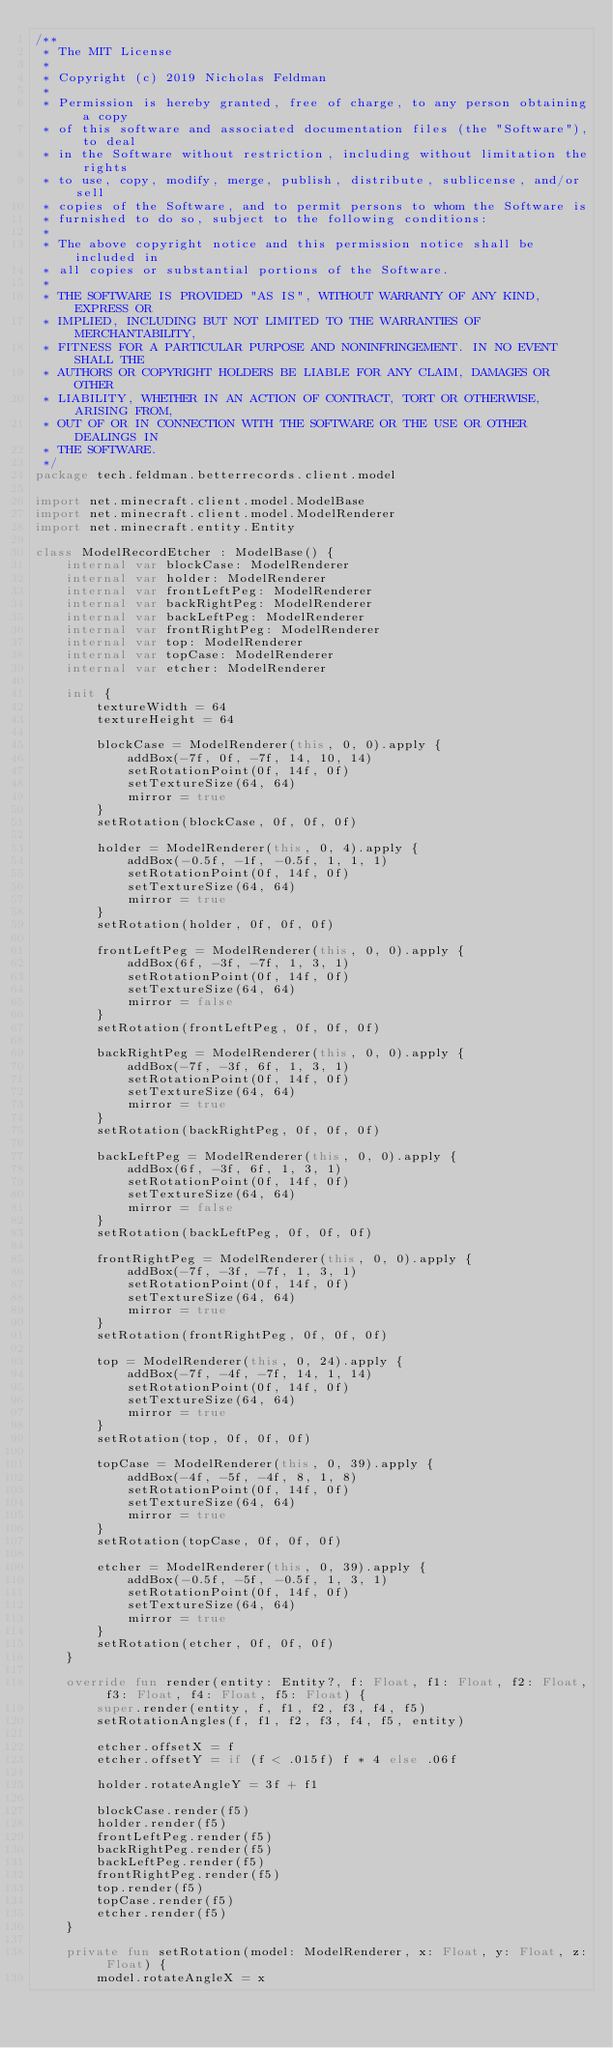<code> <loc_0><loc_0><loc_500><loc_500><_Kotlin_>/**
 * The MIT License
 *
 * Copyright (c) 2019 Nicholas Feldman
 *
 * Permission is hereby granted, free of charge, to any person obtaining a copy
 * of this software and associated documentation files (the "Software"), to deal
 * in the Software without restriction, including without limitation the rights
 * to use, copy, modify, merge, publish, distribute, sublicense, and/or sell
 * copies of the Software, and to permit persons to whom the Software is
 * furnished to do so, subject to the following conditions:
 *
 * The above copyright notice and this permission notice shall be included in
 * all copies or substantial portions of the Software.
 *
 * THE SOFTWARE IS PROVIDED "AS IS", WITHOUT WARRANTY OF ANY KIND, EXPRESS OR
 * IMPLIED, INCLUDING BUT NOT LIMITED TO THE WARRANTIES OF MERCHANTABILITY,
 * FITNESS FOR A PARTICULAR PURPOSE AND NONINFRINGEMENT. IN NO EVENT SHALL THE
 * AUTHORS OR COPYRIGHT HOLDERS BE LIABLE FOR ANY CLAIM, DAMAGES OR OTHER
 * LIABILITY, WHETHER IN AN ACTION OF CONTRACT, TORT OR OTHERWISE, ARISING FROM,
 * OUT OF OR IN CONNECTION WITH THE SOFTWARE OR THE USE OR OTHER DEALINGS IN
 * THE SOFTWARE.
 */
package tech.feldman.betterrecords.client.model

import net.minecraft.client.model.ModelBase
import net.minecraft.client.model.ModelRenderer
import net.minecraft.entity.Entity

class ModelRecordEtcher : ModelBase() {
    internal var blockCase: ModelRenderer
    internal var holder: ModelRenderer
    internal var frontLeftPeg: ModelRenderer
    internal var backRightPeg: ModelRenderer
    internal var backLeftPeg: ModelRenderer
    internal var frontRightPeg: ModelRenderer
    internal var top: ModelRenderer
    internal var topCase: ModelRenderer
    internal var etcher: ModelRenderer

    init {
        textureWidth = 64
        textureHeight = 64

        blockCase = ModelRenderer(this, 0, 0).apply {
            addBox(-7f, 0f, -7f, 14, 10, 14)
            setRotationPoint(0f, 14f, 0f)
            setTextureSize(64, 64)
            mirror = true
        }
        setRotation(blockCase, 0f, 0f, 0f)

        holder = ModelRenderer(this, 0, 4).apply {
            addBox(-0.5f, -1f, -0.5f, 1, 1, 1)
            setRotationPoint(0f, 14f, 0f)
            setTextureSize(64, 64)
            mirror = true
        }
        setRotation(holder, 0f, 0f, 0f)

        frontLeftPeg = ModelRenderer(this, 0, 0).apply {
            addBox(6f, -3f, -7f, 1, 3, 1)
            setRotationPoint(0f, 14f, 0f)
            setTextureSize(64, 64)
            mirror = false
        }
        setRotation(frontLeftPeg, 0f, 0f, 0f)

        backRightPeg = ModelRenderer(this, 0, 0).apply {
            addBox(-7f, -3f, 6f, 1, 3, 1)
            setRotationPoint(0f, 14f, 0f)
            setTextureSize(64, 64)
            mirror = true
        }
        setRotation(backRightPeg, 0f, 0f, 0f)

        backLeftPeg = ModelRenderer(this, 0, 0).apply {
            addBox(6f, -3f, 6f, 1, 3, 1)
            setRotationPoint(0f, 14f, 0f)
            setTextureSize(64, 64)
            mirror = false
        }
        setRotation(backLeftPeg, 0f, 0f, 0f)

        frontRightPeg = ModelRenderer(this, 0, 0).apply {
            addBox(-7f, -3f, -7f, 1, 3, 1)
            setRotationPoint(0f, 14f, 0f)
            setTextureSize(64, 64)
            mirror = true
        }
        setRotation(frontRightPeg, 0f, 0f, 0f)

        top = ModelRenderer(this, 0, 24).apply {
            addBox(-7f, -4f, -7f, 14, 1, 14)
            setRotationPoint(0f, 14f, 0f)
            setTextureSize(64, 64)
            mirror = true
        }
        setRotation(top, 0f, 0f, 0f)

        topCase = ModelRenderer(this, 0, 39).apply {
            addBox(-4f, -5f, -4f, 8, 1, 8)
            setRotationPoint(0f, 14f, 0f)
            setTextureSize(64, 64)
            mirror = true
        }
        setRotation(topCase, 0f, 0f, 0f)

        etcher = ModelRenderer(this, 0, 39).apply {
            addBox(-0.5f, -5f, -0.5f, 1, 3, 1)
            setRotationPoint(0f, 14f, 0f)
            setTextureSize(64, 64)
            mirror = true
        }
        setRotation(etcher, 0f, 0f, 0f)
    }

    override fun render(entity: Entity?, f: Float, f1: Float, f2: Float, f3: Float, f4: Float, f5: Float) {
        super.render(entity, f, f1, f2, f3, f4, f5)
        setRotationAngles(f, f1, f2, f3, f4, f5, entity)

        etcher.offsetX = f
        etcher.offsetY = if (f < .015f) f * 4 else .06f

        holder.rotateAngleY = 3f + f1

        blockCase.render(f5)
        holder.render(f5)
        frontLeftPeg.render(f5)
        backRightPeg.render(f5)
        backLeftPeg.render(f5)
        frontRightPeg.render(f5)
        top.render(f5)
        topCase.render(f5)
        etcher.render(f5)
    }

    private fun setRotation(model: ModelRenderer, x: Float, y: Float, z: Float) {
        model.rotateAngleX = x</code> 